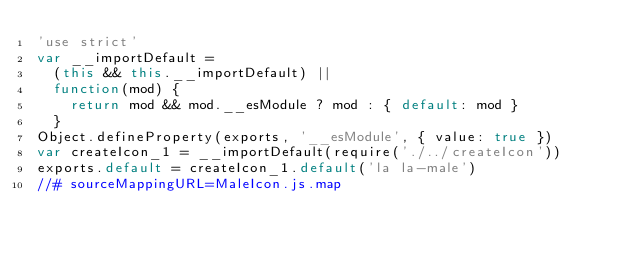<code> <loc_0><loc_0><loc_500><loc_500><_JavaScript_>'use strict'
var __importDefault =
  (this && this.__importDefault) ||
  function(mod) {
    return mod && mod.__esModule ? mod : { default: mod }
  }
Object.defineProperty(exports, '__esModule', { value: true })
var createIcon_1 = __importDefault(require('./../createIcon'))
exports.default = createIcon_1.default('la la-male')
//# sourceMappingURL=MaleIcon.js.map
</code> 